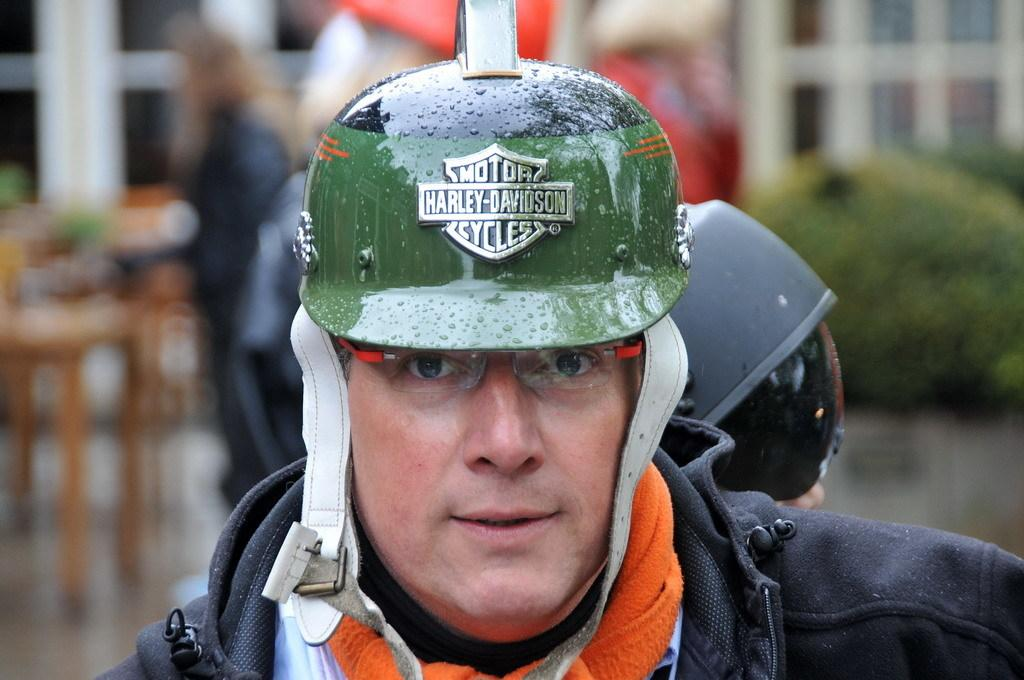How many people are in the image? There are people in the image. Can you describe the headgear of some of the people? Two of the people are wearing helmets. Is there any text on any of the helmets? Yes, there is text on one of the helmets. What type of structure can be seen in the image? There is a house in the image. What other elements are present in the image? There are plants in the image. How would you describe the background of the image? The background of the image is blurred. How many giants are visible in the image? There are no giants present in the image. What type of yard can be seen in the image? There is no yard visible in the image. 